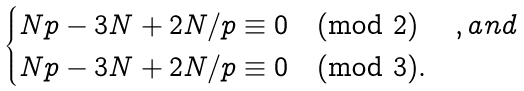<formula> <loc_0><loc_0><loc_500><loc_500>\begin{cases} N p - 3 N + 2 N / p \equiv 0 \pmod { 2 } & , a n d \\ N p - 3 N + 2 N / p \equiv 0 \pmod { 3 } . \end{cases}</formula> 